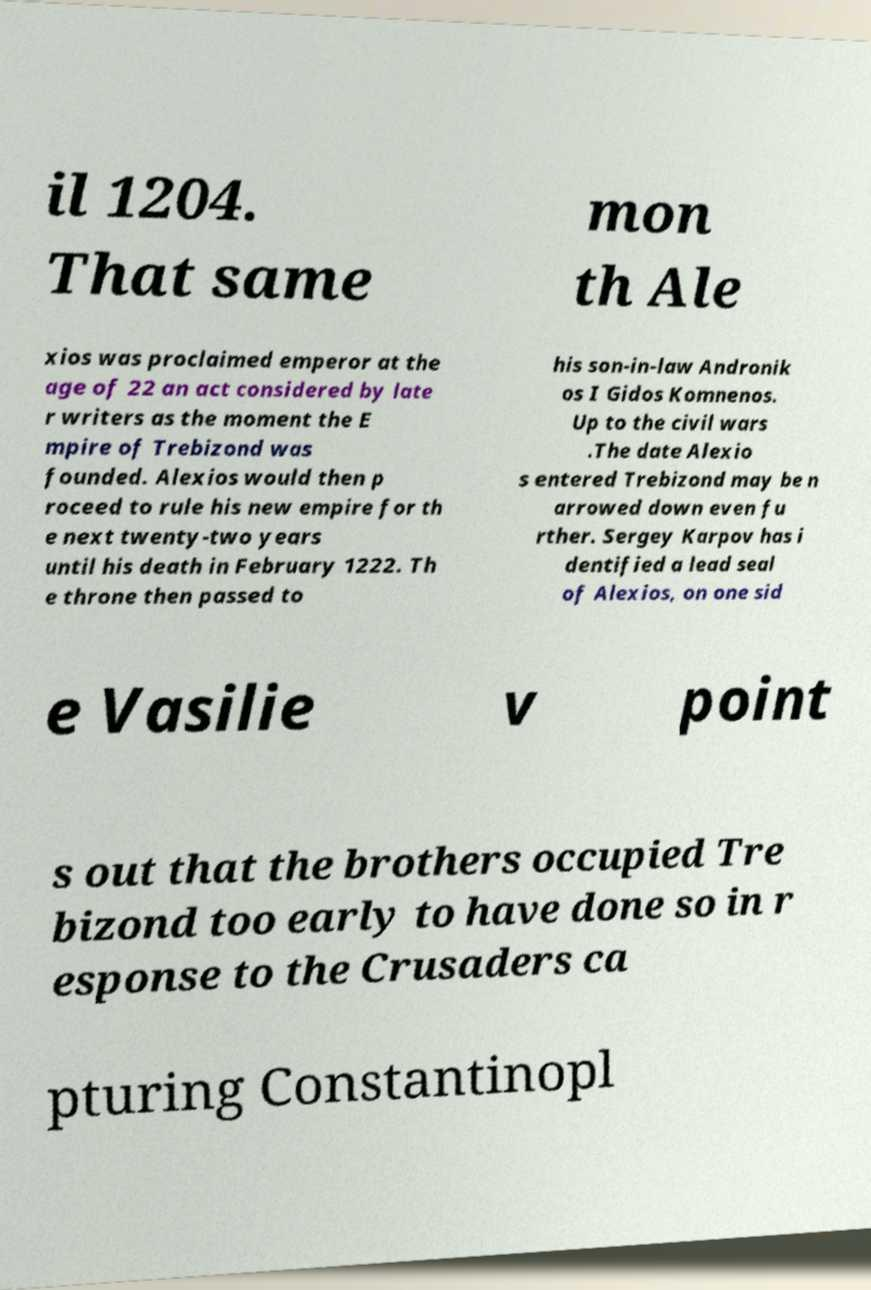Please identify and transcribe the text found in this image. il 1204. That same mon th Ale xios was proclaimed emperor at the age of 22 an act considered by late r writers as the moment the E mpire of Trebizond was founded. Alexios would then p roceed to rule his new empire for th e next twenty-two years until his death in February 1222. Th e throne then passed to his son-in-law Andronik os I Gidos Komnenos. Up to the civil wars .The date Alexio s entered Trebizond may be n arrowed down even fu rther. Sergey Karpov has i dentified a lead seal of Alexios, on one sid e Vasilie v point s out that the brothers occupied Tre bizond too early to have done so in r esponse to the Crusaders ca pturing Constantinopl 